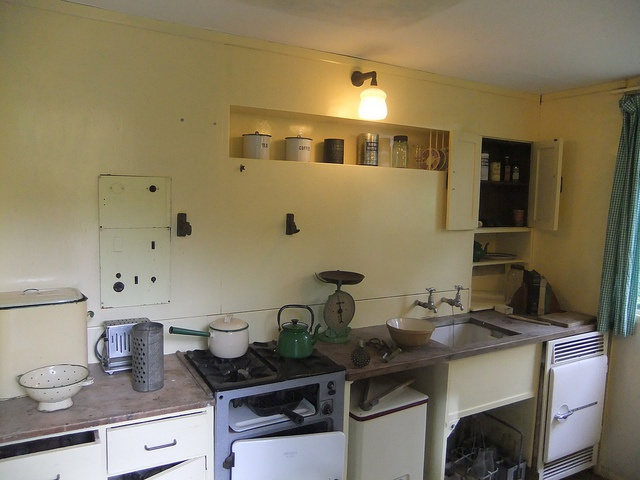Describe the objects in this image and their specific colors. I can see oven in olive, black, gray, and darkgray tones, bowl in olive, darkgray, lightgray, and gray tones, sink in olive, gray, and black tones, bowl in olive, black, gray, and maroon tones, and book in black, gray, and olive tones in this image. 